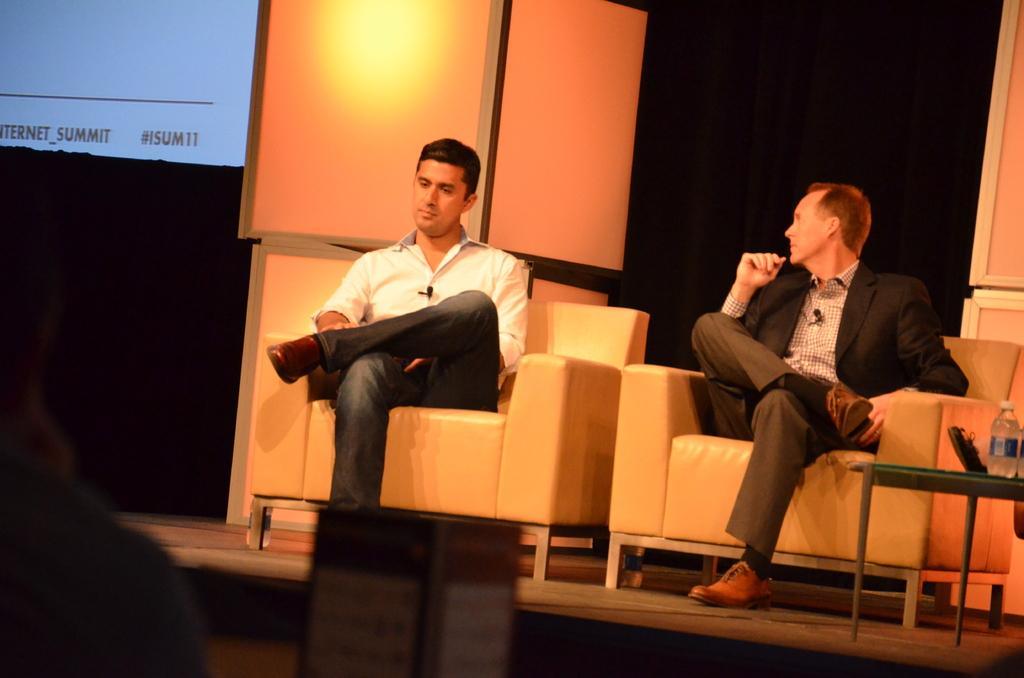Could you give a brief overview of what you see in this image? In this image I can see two people sitting on the couch. These people are wearing the different color dresses. To the right I can see the bottle on the table. To the left I can see the screen and there is a black background. 